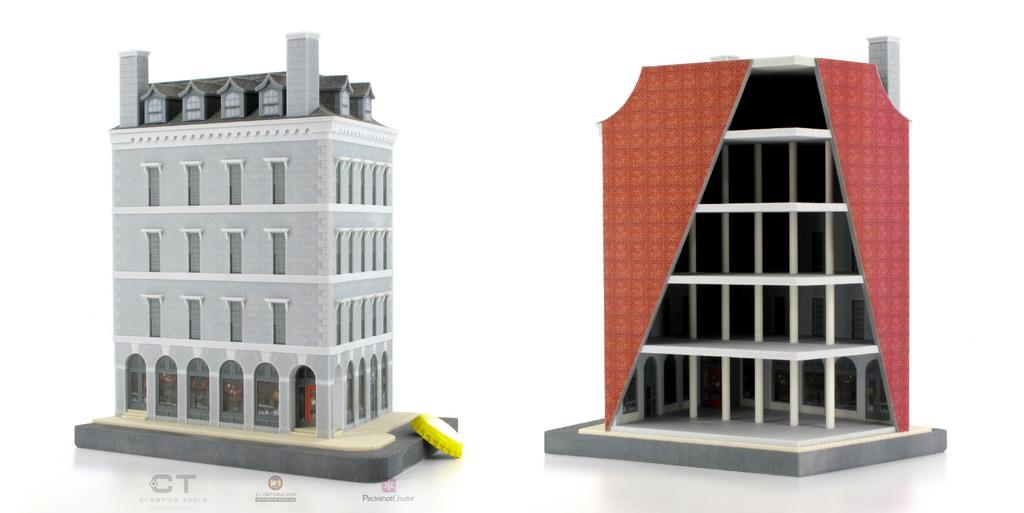What can be seen on the left side of the image? There is a model of a building on the left side of the image. What is present on the right side of the image? There is a model of a building on the right side of the image. Is there any text or marking at the bottom of the image? Yes, there is a watermark at the bottom of the image. What type of sock is being worn by the society in the image? There is no society or sock present in the image; it features two model buildings and a watermark. 